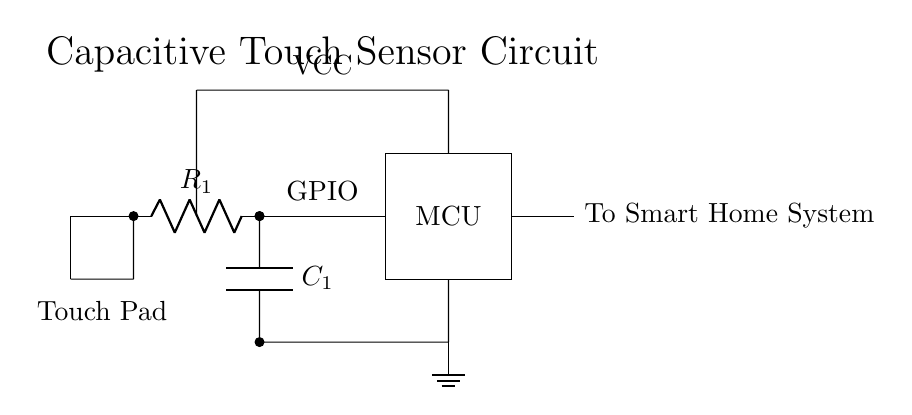What is the function of C1 in the circuit? C1 acts as a capacitor in the touch sensor circuit, which is essential for detecting changes in capacitance when a user touches the touch pad. This change is processed by the microcontroller to determine a touch event.
Answer: Capacitor What type of component is R1? R1 is a resistor in the circuit. Resistors limit the current flow and can affect the timing characteristics of the circuit, which is important in touch sensing applications.
Answer: Resistor What is the expected output from the MCU? The MCU processes the signal from the touch pad and produces a signal indicating whether a touch has been detected, which is outputted to the Smart Home System as a digital signal.
Answer: Digital signal What voltage is VCC in the circuit? The VCC node typically represents the supply voltage used to power the circuit components, which is often 5V in low power appliances circuits.
Answer: 5V Which component connects the touch pad to the microcontroller? The connection between the touch pad and the microcontroller is made through the resistor R1. When a touch is detected, the capacitance change across C1 affects the voltage seen at the GPIO connection to the MCU.
Answer: Resistor What is the purpose of the ground connection? The ground connection provides a common return path for current in the circuit, ensuring that all components operate at a common reference voltage, which is crucial for the correct functioning of the circuit.
Answer: Common return path How does the circuit detect a touch event? The circuit detects a touch event through the change in capacitance at the touch pad when a finger is placed on it. This change alters the charge across capacitor C1, which is then measured by the MCU to determine if a touch occurred.
Answer: Change in capacitance 